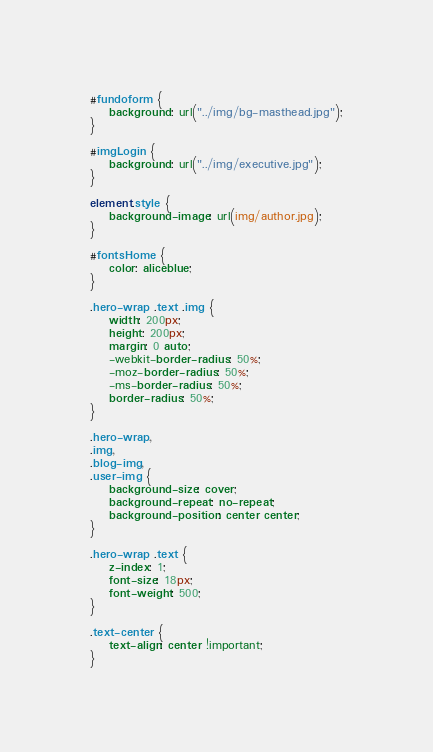Convert code to text. <code><loc_0><loc_0><loc_500><loc_500><_CSS_>#fundoform {
    background: url("../img/bg-masthead.jpg");
}

#imgLogin {
    background: url("../img/executive.jpg");
}

element.style {
    background-image: url(img/author.jpg);
}

#fontsHome {
    color: aliceblue;
}

.hero-wrap .text .img {
    width: 200px;
    height: 200px;
    margin: 0 auto;
    -webkit-border-radius: 50%;
    -moz-border-radius: 50%;
    -ms-border-radius: 50%;
    border-radius: 50%;
}

.hero-wrap,
.img,
.blog-img,
.user-img {
    background-size: cover;
    background-repeat: no-repeat;
    background-position: center center;
}

.hero-wrap .text {
    z-index: 1;
    font-size: 18px;
    font-weight: 500;
}

.text-center {
    text-align: center !important;
}</code> 